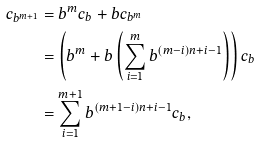Convert formula to latex. <formula><loc_0><loc_0><loc_500><loc_500>c _ { b ^ { m + 1 } } & = b ^ { m } c _ { b } + b c _ { b ^ { m } } \\ & = \left ( b ^ { m } + b \left ( \sum _ { i = 1 } ^ { m } b ^ { ( m - i ) n + i - 1 } \right ) \right ) c _ { b } \\ & = \sum _ { i = 1 } ^ { m + 1 } b ^ { ( m + 1 - i ) n + i - 1 } c _ { b } ,</formula> 